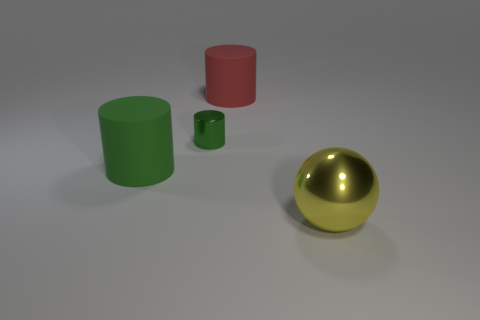Is there an indication in the image that would imply the purpose of these objects? The image does not provide any context that signifies a particular use; it looks like a simple display of geometric shapes with various colors and materials. 